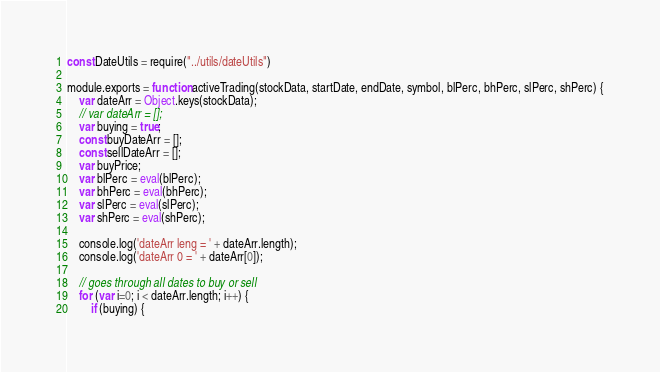<code> <loc_0><loc_0><loc_500><loc_500><_JavaScript_>const DateUtils = require("../utils/dateUtils")

module.exports = function activeTrading(stockData, startDate, endDate, symbol, blPerc, bhPerc, slPerc, shPerc) {
    var dateArr = Object.keys(stockData);
    // var dateArr = [];
    var buying = true;
    const buyDateArr = [];
    const sellDateArr = [];
    var buyPrice;
    var blPerc = eval(blPerc);
    var bhPerc = eval(bhPerc);
    var slPerc = eval(slPerc);
    var shPerc = eval(shPerc);

    console.log('dateArr leng = ' + dateArr.length);
    console.log('dateArr 0 = ' + dateArr[0]);

    // goes through all dates to buy or sell
    for (var i=0; i < dateArr.length; i++) {
        if (buying) {</code> 